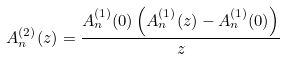Convert formula to latex. <formula><loc_0><loc_0><loc_500><loc_500>A _ { n } ^ { ( 2 ) } ( z ) = \frac { A _ { n } ^ { ( 1 ) } ( 0 ) \left ( A _ { n } ^ { ( 1 ) } ( z ) - A _ { n } ^ { ( 1 ) } ( 0 ) \right ) } { z }</formula> 